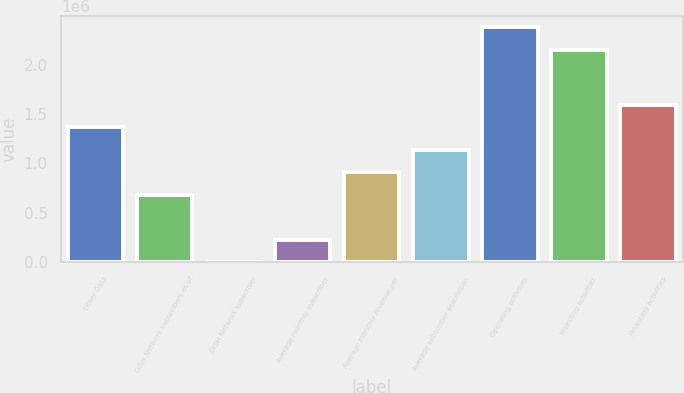Convert chart. <chart><loc_0><loc_0><loc_500><loc_500><bar_chart><fcel>Other Data<fcel>DISH Network subscribers as of<fcel>DISH Network subscriber<fcel>Average monthly subscriber<fcel>Average monthly revenue per<fcel>Average subscriber acquisition<fcel>Operating activities<fcel>Investing activities<fcel>Financing activities<nl><fcel>1.36755e+06<fcel>683773<fcel>1.06<fcel>227925<fcel>911697<fcel>1.13962e+06<fcel>2.37689e+06<fcel>2.14897e+06<fcel>1.59547e+06<nl></chart> 